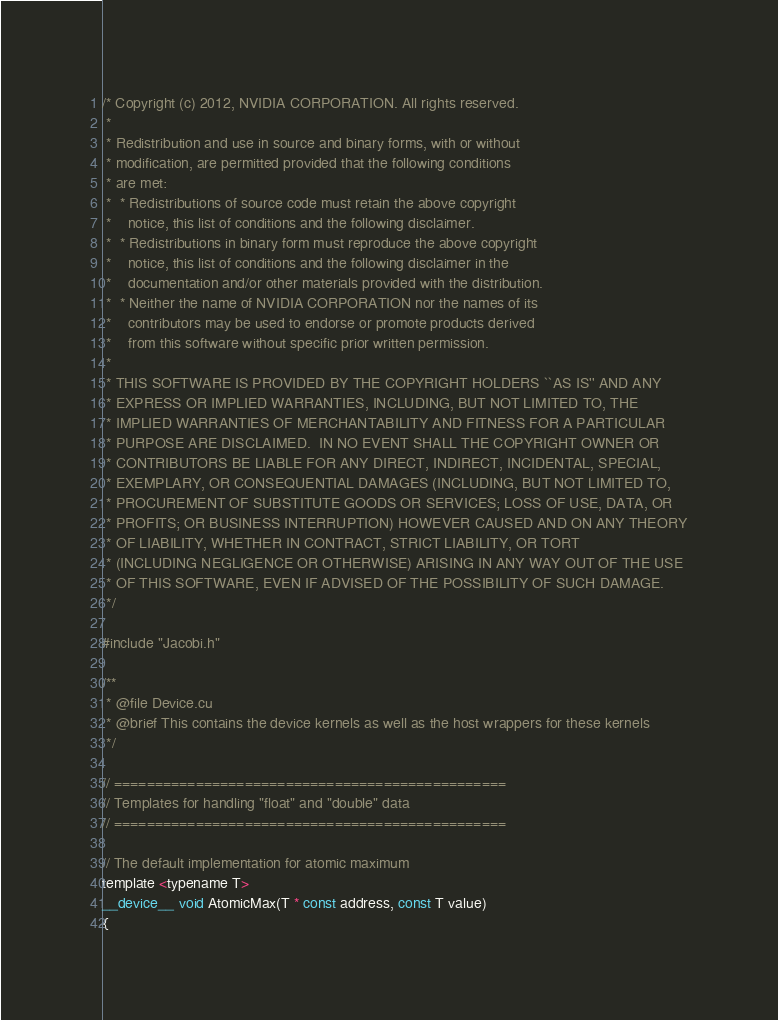Convert code to text. <code><loc_0><loc_0><loc_500><loc_500><_Cuda_>/* Copyright (c) 2012, NVIDIA CORPORATION. All rights reserved.
 *
 * Redistribution and use in source and binary forms, with or without
 * modification, are permitted provided that the following conditions
 * are met:
 *  * Redistributions of source code must retain the above copyright
 *    notice, this list of conditions and the following disclaimer.
 *  * Redistributions in binary form must reproduce the above copyright
 *    notice, this list of conditions and the following disclaimer in the
 *    documentation and/or other materials provided with the distribution.
 *  * Neither the name of NVIDIA CORPORATION nor the names of its
 *    contributors may be used to endorse or promote products derived
 *    from this software without specific prior written permission.
 *
 * THIS SOFTWARE IS PROVIDED BY THE COPYRIGHT HOLDERS ``AS IS'' AND ANY
 * EXPRESS OR IMPLIED WARRANTIES, INCLUDING, BUT NOT LIMITED TO, THE
 * IMPLIED WARRANTIES OF MERCHANTABILITY AND FITNESS FOR A PARTICULAR
 * PURPOSE ARE DISCLAIMED.  IN NO EVENT SHALL THE COPYRIGHT OWNER OR
 * CONTRIBUTORS BE LIABLE FOR ANY DIRECT, INDIRECT, INCIDENTAL, SPECIAL,
 * EXEMPLARY, OR CONSEQUENTIAL DAMAGES (INCLUDING, BUT NOT LIMITED TO,
 * PROCUREMENT OF SUBSTITUTE GOODS OR SERVICES; LOSS OF USE, DATA, OR
 * PROFITS; OR BUSINESS INTERRUPTION) HOWEVER CAUSED AND ON ANY THEORY
 * OF LIABILITY, WHETHER IN CONTRACT, STRICT LIABILITY, OR TORT
 * (INCLUDING NEGLIGENCE OR OTHERWISE) ARISING IN ANY WAY OUT OF THE USE
 * OF THIS SOFTWARE, EVEN IF ADVISED OF THE POSSIBILITY OF SUCH DAMAGE.
 */

#include "Jacobi.h"

/**
 * @file Device.cu
 * @brief This contains the device kernels as well as the host wrappers for these kernels
 */

// ================================================
// Templates for handling "float" and "double" data
// ================================================

// The default implementation for atomic maximum
template <typename T>
__device__ void AtomicMax(T * const address, const T value)
{</code> 